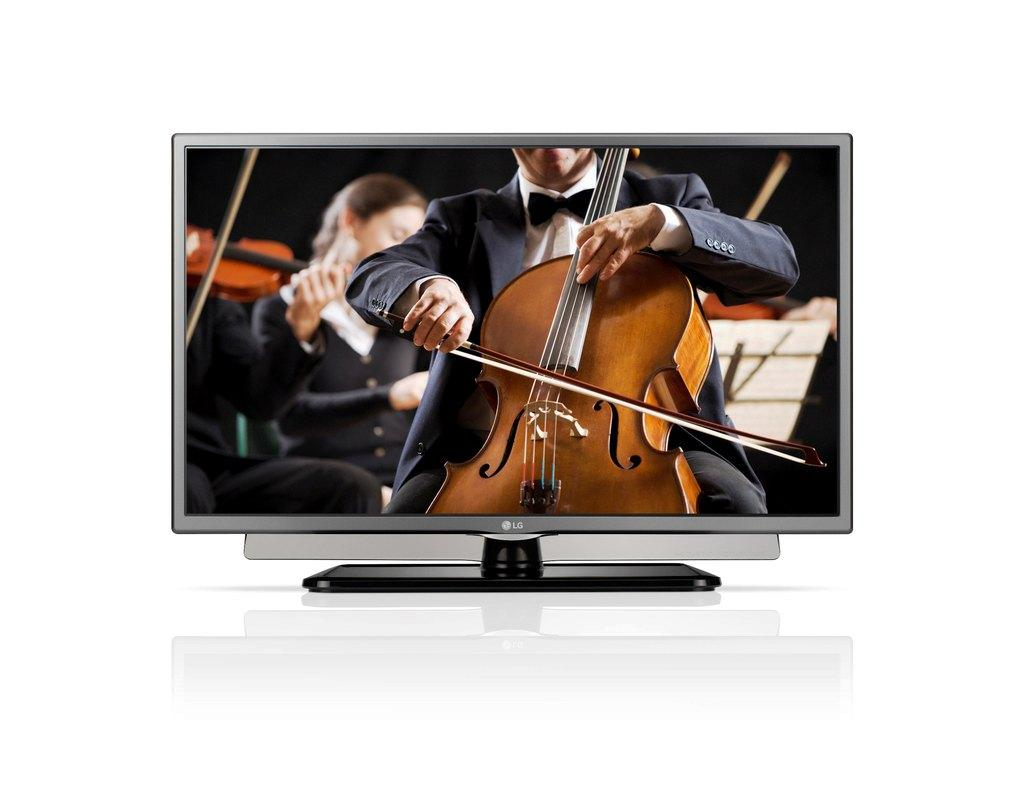What electronic device can be seen in the image? There is a television in the image. What activity is the person in the foreground engaged in? The person is sitting and playing the violin. Can you describe the people in the background? There are other persons sitting in the background. What type of bone can be seen in the image? There is no bone present in the image. Can you describe the mist in the image? There is no mist present in the image. 